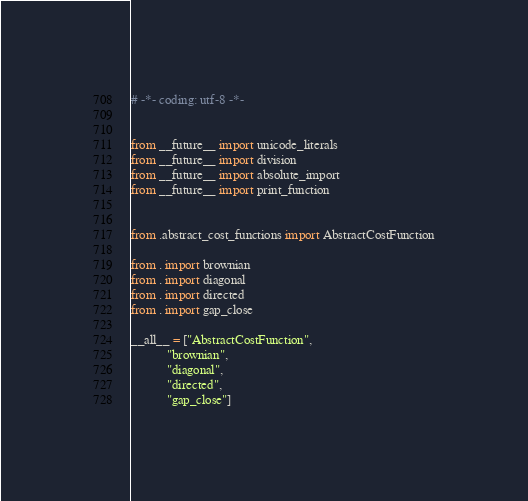Convert code to text. <code><loc_0><loc_0><loc_500><loc_500><_Python_>
# -*- coding: utf-8 -*-


from __future__ import unicode_literals
from __future__ import division
from __future__ import absolute_import
from __future__ import print_function


from .abstract_cost_functions import AbstractCostFunction

from . import brownian
from . import diagonal
from . import directed
from . import gap_close

__all__ = ["AbstractCostFunction",
           "brownian",
           "diagonal",
           "directed",
           "gap_close"]
</code> 